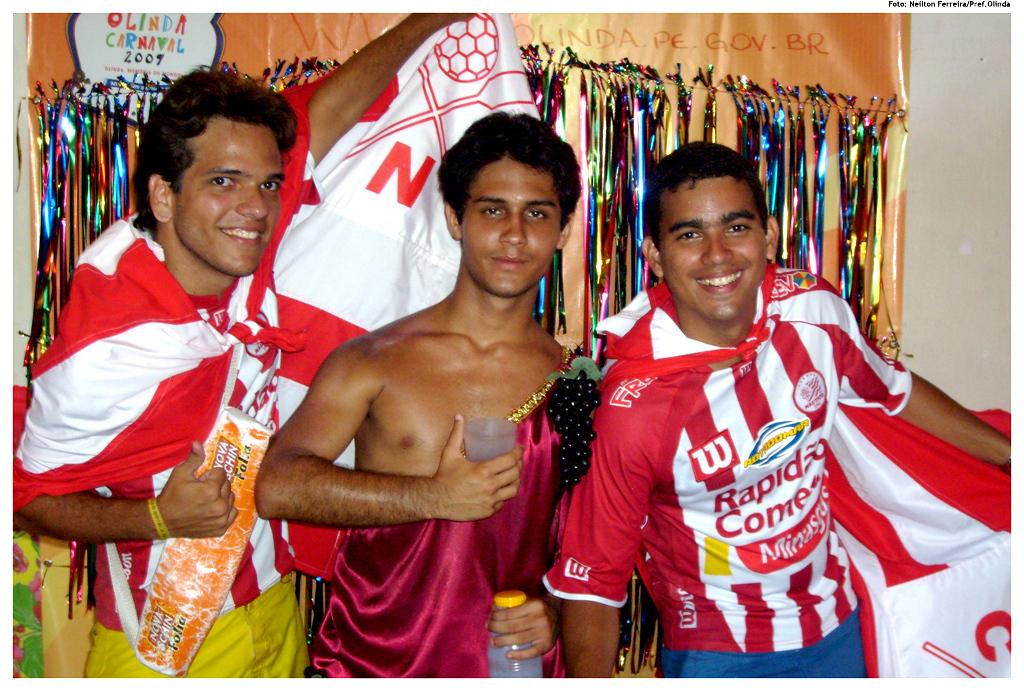<image>
Present a compact description of the photo's key features. A group of men celebrate together for the team Rapid Come. 